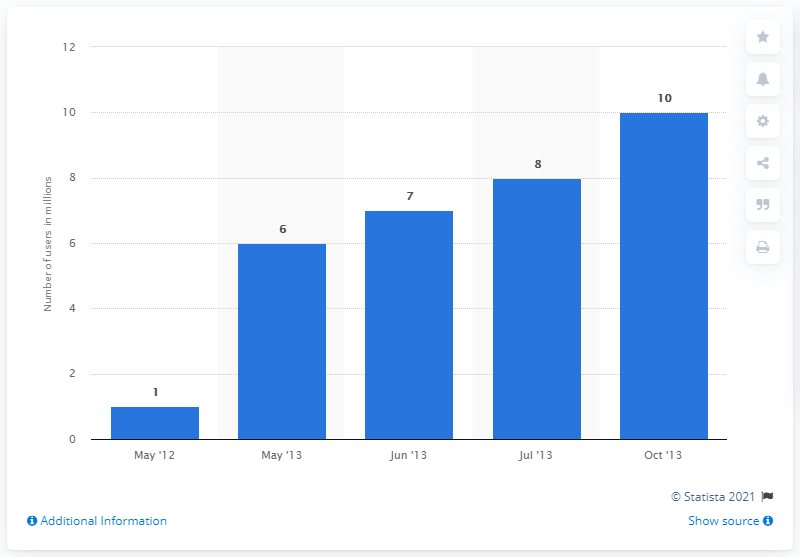Indicate a few pertinent items in this graphic. As of May 2013, Fancy had approximately 6 registered users. In October 2013, Fancy had 8 registered users. Out of the total number of bars that exceed 5, there are 4 of them. The average value for the past three months is 8.33... 